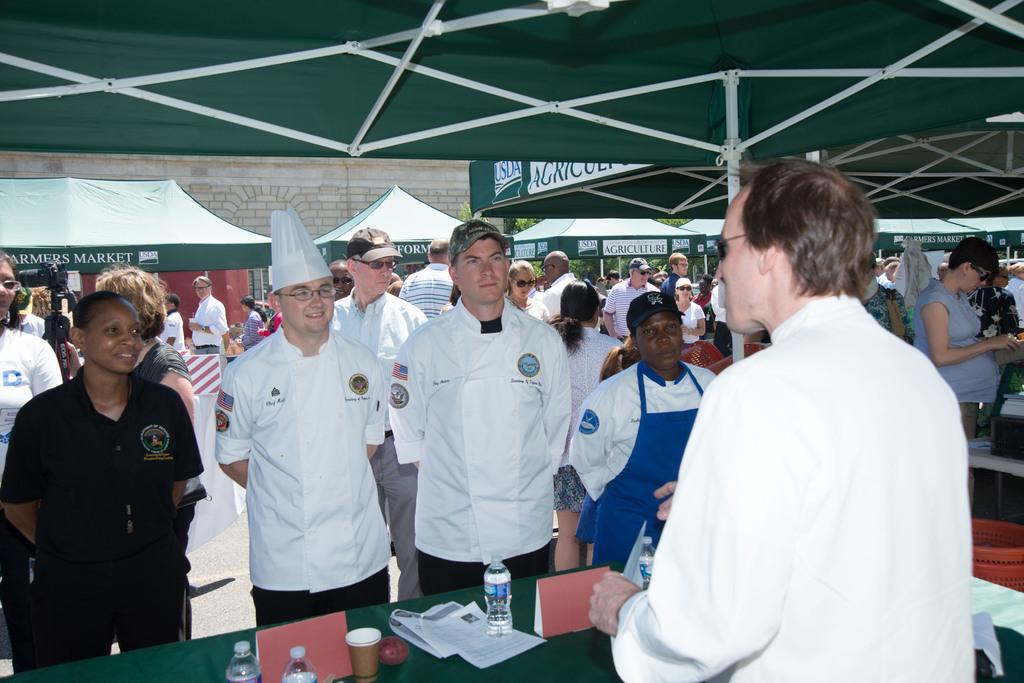Can you describe this image briefly? In the picture I can see a person wearing a white color dress is standing on the right side of the image. Here we can see a few more people are standing near the table where water bottles, some papers, name boards and the cup are placed on the green color tablecloth. In the background, we can see a few more people standing on the road, we can see the green color tents, trees and the stone wall. 